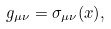Convert formula to latex. <formula><loc_0><loc_0><loc_500><loc_500>g _ { \mu \nu } = \sigma _ { \mu \nu } ( x ) ,</formula> 